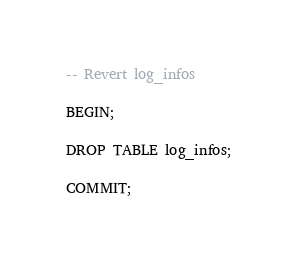Convert code to text. <code><loc_0><loc_0><loc_500><loc_500><_SQL_>-- Revert log_infos

BEGIN;

DROP TABLE log_infos;

COMMIT;
</code> 